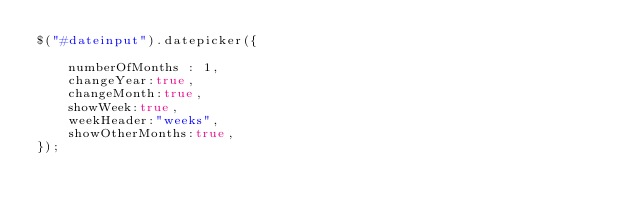<code> <loc_0><loc_0><loc_500><loc_500><_JavaScript_>$("#dateinput").datepicker({

	numberOfMonths : 1,
	changeYear:true,
	changeMonth:true,
	showWeek:true,
	weekHeader:"weeks",
	showOtherMonths:true,
});


</code> 